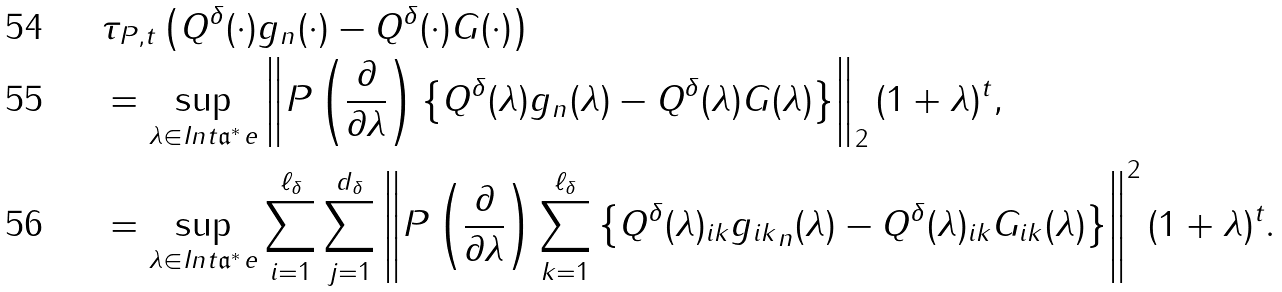Convert formula to latex. <formula><loc_0><loc_0><loc_500><loc_500>& \tau _ { P , t } \left ( Q ^ { \delta } ( \cdot ) g _ { n } ( \cdot ) - Q ^ { \delta } ( \cdot ) G ( \cdot ) \right ) \\ & = \sup _ { \lambda \in I n t \mathfrak a ^ { * } _ { \ } e } \left \| P \left ( \frac { \partial } { \partial \lambda } \right ) \left \{ Q ^ { \delta } ( \lambda ) g _ { n } ( \lambda ) - Q ^ { \delta } ( \lambda ) G ( \lambda ) \right \} \right \| _ { 2 } ( 1 + \| \lambda \| ) ^ { t } , \\ & = \sup _ { \lambda \in I n t \mathfrak a ^ { * } _ { \ } e } \sum _ { i = 1 } ^ { \ell _ { \delta } } \sum _ { j = 1 } ^ { d _ { \delta } } \left \| P \left ( \frac { \partial } { \partial \lambda } \right ) \sum _ { k = 1 } ^ { \ell _ { \delta } } \left \{ Q ^ { \delta } ( \lambda ) _ { i k } { g _ { i k } } _ { n } ( \lambda ) - Q ^ { \delta } ( \lambda ) _ { i k } G _ { i k } ( \lambda ) \right \} \right \| ^ { 2 } ( 1 + \| \lambda \| ) ^ { t } .</formula> 